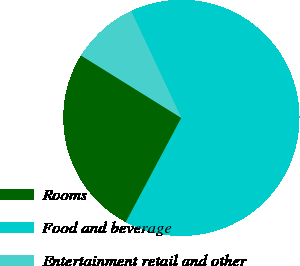Convert chart to OTSL. <chart><loc_0><loc_0><loc_500><loc_500><pie_chart><fcel>Rooms<fcel>Food and beverage<fcel>Entertainment retail and other<nl><fcel>26.07%<fcel>64.78%<fcel>9.14%<nl></chart> 